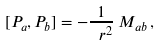Convert formula to latex. <formula><loc_0><loc_0><loc_500><loc_500>[ P _ { a } , P _ { b } ] = - \frac { 1 } { \ r ^ { 2 } } \, M _ { a b } \, ,</formula> 